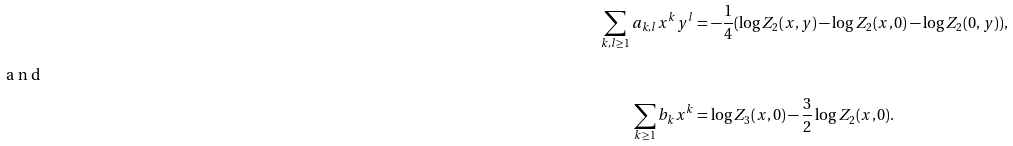Convert formula to latex. <formula><loc_0><loc_0><loc_500><loc_500>\sum _ { k , l \geq 1 } a _ { k , l } x ^ { k } y ^ { l } & = - \frac { 1 } { 4 } ( \log Z _ { 2 } ( x , y ) - \log Z _ { 2 } ( x , 0 ) - \log Z _ { 2 } ( 0 , y ) ) , \\ \intertext { a n d } \sum _ { k \geq 1 } b _ { k } x ^ { k } & = \log Z _ { 3 } ( x , 0 ) - \frac { 3 } { 2 } \log Z _ { 2 } ( x , 0 ) .</formula> 